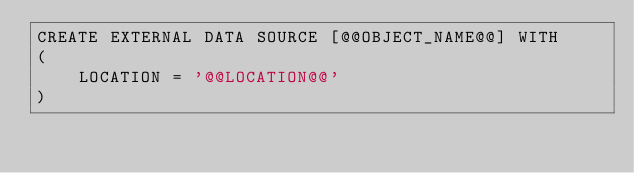Convert code to text. <code><loc_0><loc_0><loc_500><loc_500><_SQL_>CREATE EXTERNAL DATA SOURCE [@@OBJECT_NAME@@] WITH
(
	LOCATION = '@@LOCATION@@'
)
</code> 